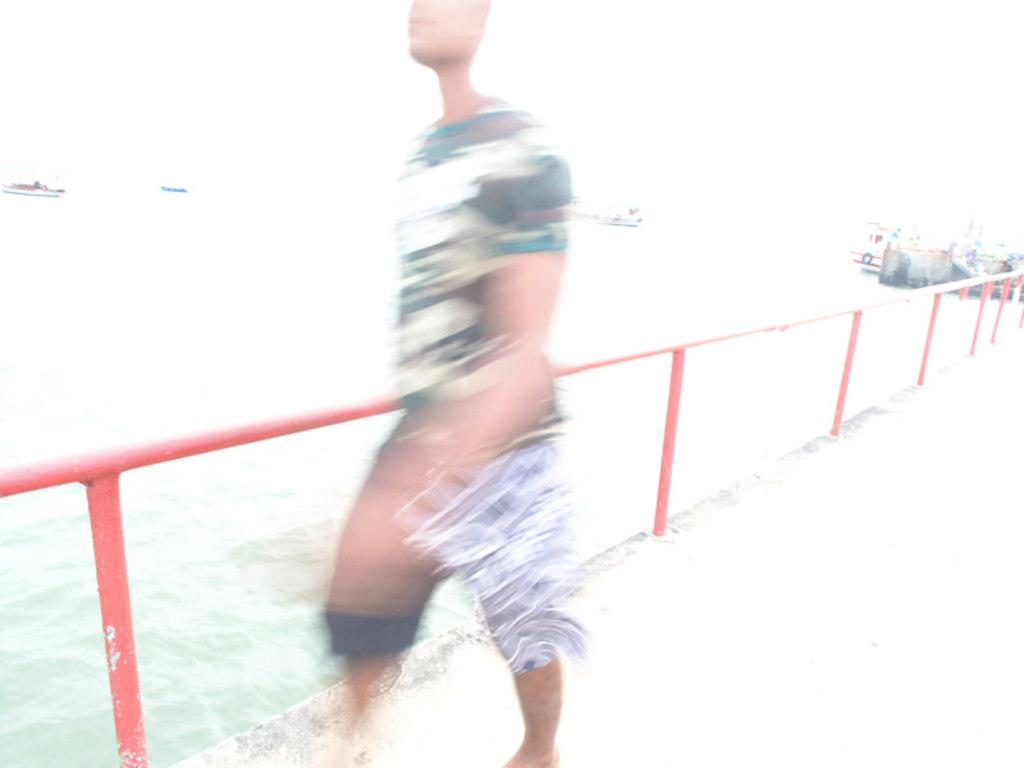What is the main subject in the foreground of the image? There is a blurry image of a person in the foreground of the foreground of the image. What is located behind the person? There is railing behind the person. What can be seen beyond the railing? There is water visible behind the railing. What other elements can be seen in the background of the image? There are other unspecified elements in the background of the image. What type of juice is being taught by the person in the image? There is no person teaching any type of juice in the image, as the person is blurry and there is no indication of teaching or juice in the image. 